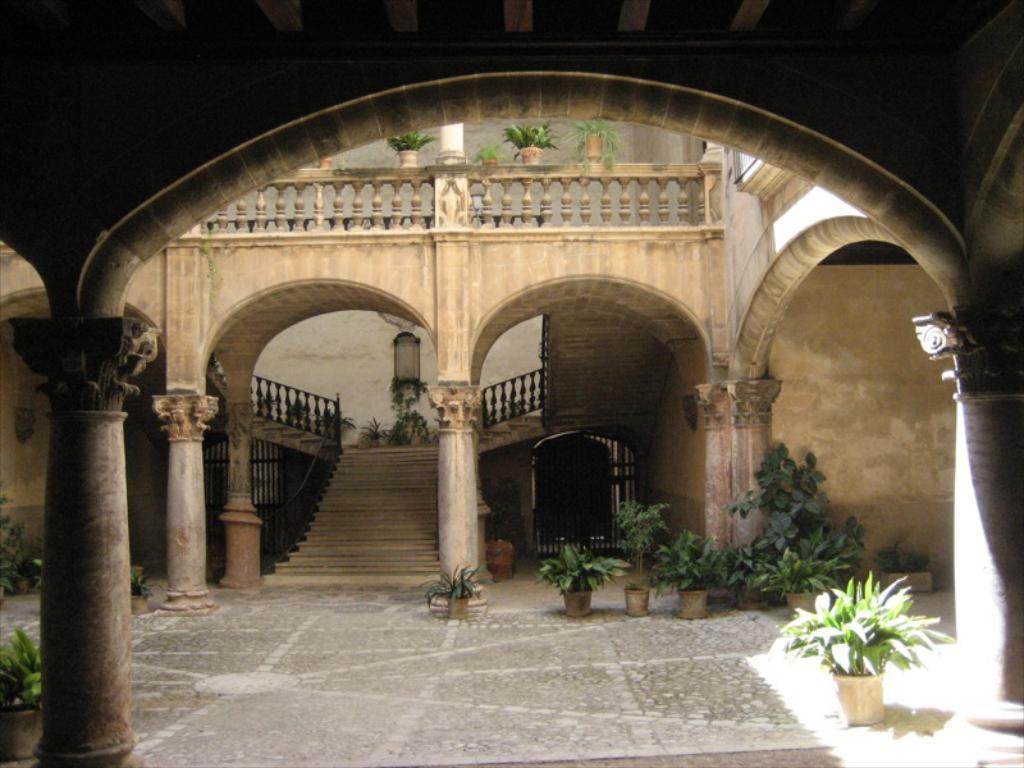In one or two sentences, can you explain what this image depicts? In this image I can see the building, few stairs, railing, pillars, wall and few flower pots. 